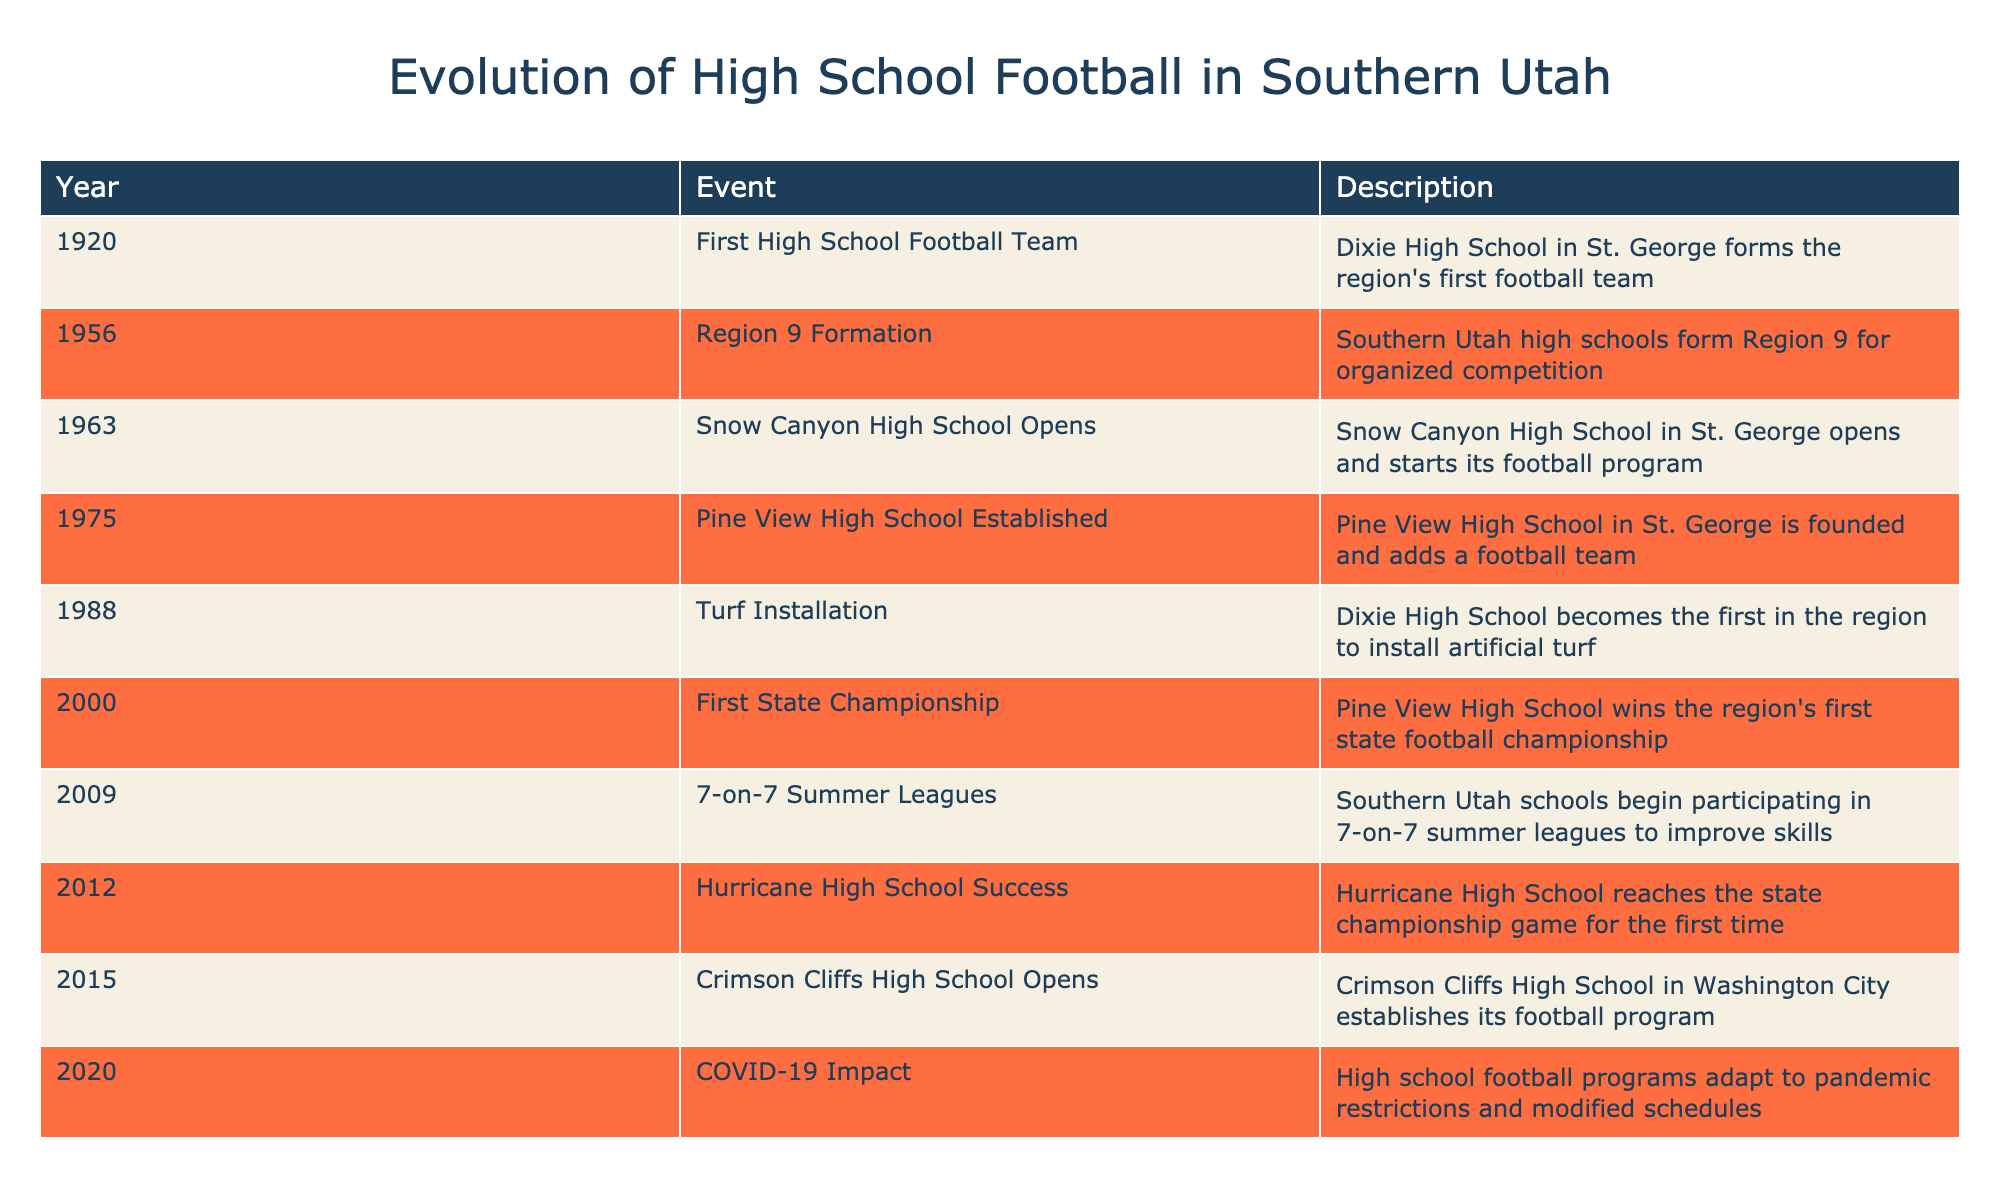What year did Dixie High School form its football team? The table shows that Dixie High School formed the region's first football team in the year 1920.
Answer: 1920 In what year was the first state championship won by a high school in the region? According to the table, Pine View High School won the region's first state football championship in the year 2000.
Answer: 2000 Did Hurricane High School ever reach the state championship game? The table indicates that Hurricane High School reached the state championship game for the first time in the year 2012, which confirms that it did.
Answer: Yes How many different high schools established football programs between 1963 and 2015? The high schools that established football programs in this period are Snow Canyon High School in 1963, Pine View High School in 1975, and Crimson Cliffs High School in 2015, making a total of 3 different schools.
Answer: 3 What was the event in 1988 regarding Dixie High School? The table states that in 1988, Dixie High School became the first in the region to install artificial turf, which is a significant event for the program.
Answer: Turf Installation Which event occurred in 2009, and why was it important? In 2009, Southern Utah schools began participating in 7-on-7 summer leagues to improve skills. This event is important as it marked an effort to enhance player development and competitiveness in football.
Answer: 7-on-7 Summer Leagues What was the timeframe between the establishment of Pine View High School and the first installation of artificial turf at Dixie High School? Pine View High School was established in 1975, and the installation of turf at Dixie High School occurred in 1988. The difference between these years is 1988 - 1975 = 13 years.
Answer: 13 years How has high school football adapted to the COVID-19 pandemic based on the table? The table mentions that in 2020, high school football programs had to adapt to pandemic restrictions and modified schedules, indicating significant changes in how the sport was managed during that year.
Answer: Adapted to pandemic restrictions When did the first organized competition region (Region 9) form for Southern Utah high schools? As per the table, Region 9 was formed for organized competition in the year 1956 among Southern Utah high schools.
Answer: 1956 